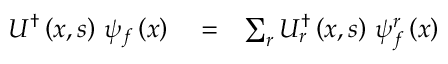<formula> <loc_0><loc_0><loc_500><loc_500>\begin{array} { r l r } { U ^ { \dag } \left ( x , s \right ) \, \psi _ { f } \left ( x \right ) } & = } & { \sum _ { r } U _ { r } ^ { \dag } \left ( x , s \right ) \, \psi _ { f } ^ { r } \left ( x \right ) } \end{array}</formula> 